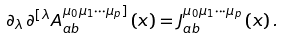Convert formula to latex. <formula><loc_0><loc_0><loc_500><loc_500>\partial _ { \lambda \, } \partial ^ { [ \lambda } A _ { a b } ^ { \mu _ { 0 } \mu _ { 1 } \cdots \mu _ { p } ] } \left ( x \right ) = J _ { a b } ^ { \mu _ { 0 } \mu _ { 1 } \cdots \mu _ { p } } \left ( x \right ) .</formula> 